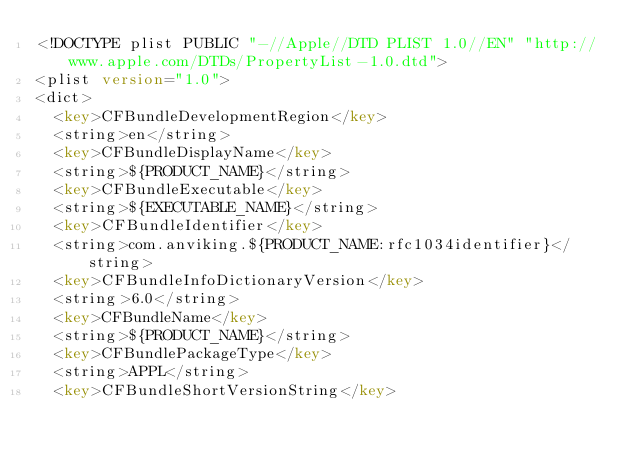<code> <loc_0><loc_0><loc_500><loc_500><_XML_><!DOCTYPE plist PUBLIC "-//Apple//DTD PLIST 1.0//EN" "http://www.apple.com/DTDs/PropertyList-1.0.dtd">
<plist version="1.0">
<dict>
	<key>CFBundleDevelopmentRegion</key>
	<string>en</string>
	<key>CFBundleDisplayName</key>
	<string>${PRODUCT_NAME}</string>
	<key>CFBundleExecutable</key>
	<string>${EXECUTABLE_NAME}</string>
	<key>CFBundleIdentifier</key>
	<string>com.anviking.${PRODUCT_NAME:rfc1034identifier}</string>
	<key>CFBundleInfoDictionaryVersion</key>
	<string>6.0</string>
	<key>CFBundleName</key>
	<string>${PRODUCT_NAME}</string>
	<key>CFBundlePackageType</key>
	<string>APPL</string>
	<key>CFBundleShortVersionString</key></code> 